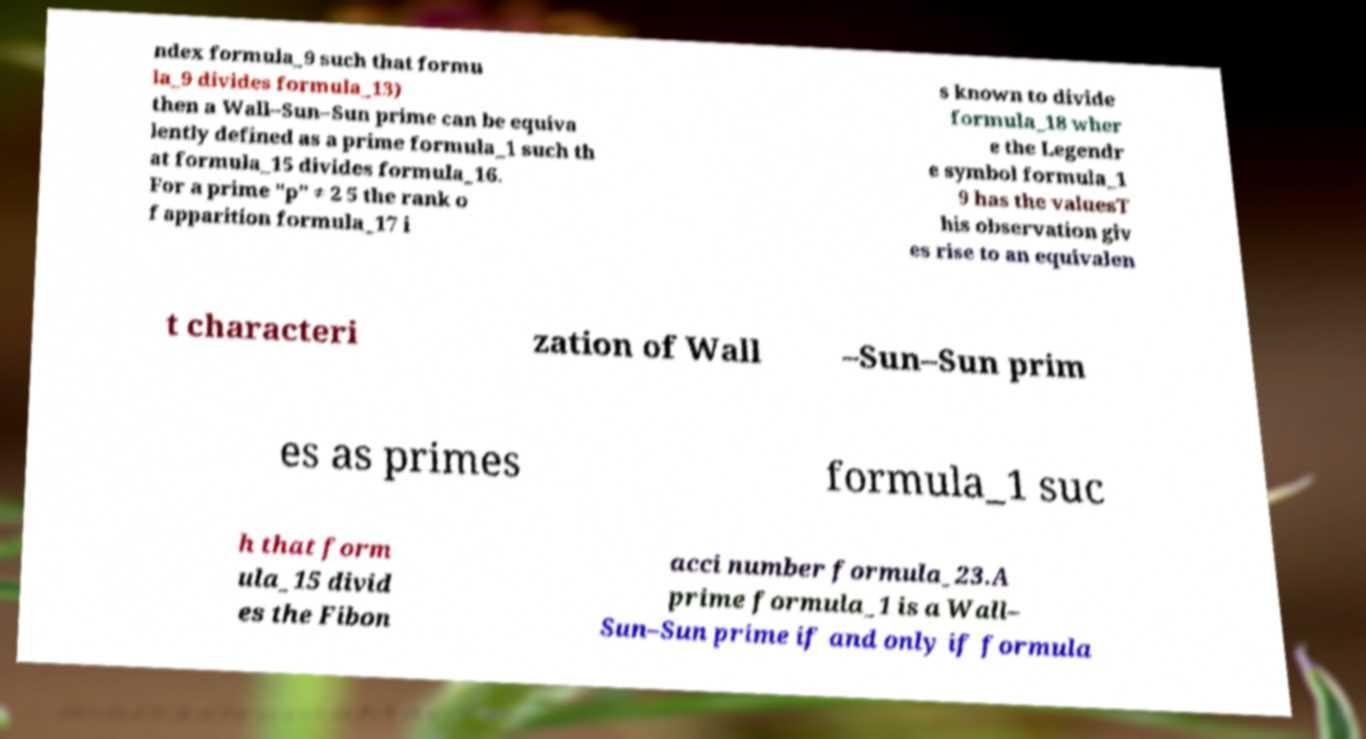Please identify and transcribe the text found in this image. ndex formula_9 such that formu la_9 divides formula_13) then a Wall–Sun–Sun prime can be equiva lently defined as a prime formula_1 such th at formula_15 divides formula_16. For a prime "p" ≠ 2 5 the rank o f apparition formula_17 i s known to divide formula_18 wher e the Legendr e symbol formula_1 9 has the valuesT his observation giv es rise to an equivalen t characteri zation of Wall –Sun–Sun prim es as primes formula_1 suc h that form ula_15 divid es the Fibon acci number formula_23.A prime formula_1 is a Wall– Sun–Sun prime if and only if formula 